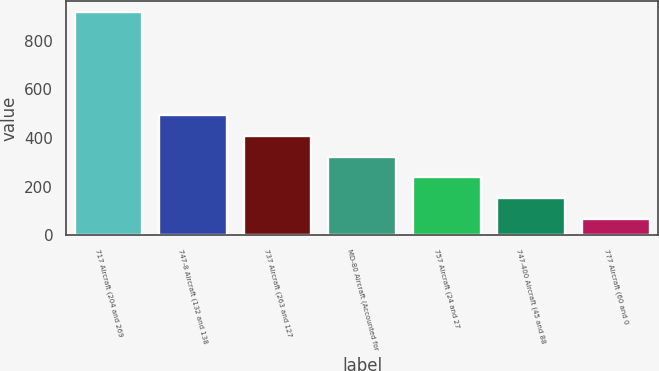<chart> <loc_0><loc_0><loc_500><loc_500><bar_chart><fcel>717 Aircraft (204 and 269<fcel>747-8 Aircraft (132 and 138<fcel>737 Aircraft (263 and 127<fcel>MD-80 Aircraft (Accounted for<fcel>757 Aircraft (24 and 27<fcel>747-400 Aircraft (45 and 88<fcel>777 Aircraft (60 and 0<nl><fcel>918<fcel>493<fcel>408<fcel>323<fcel>238<fcel>153<fcel>68<nl></chart> 